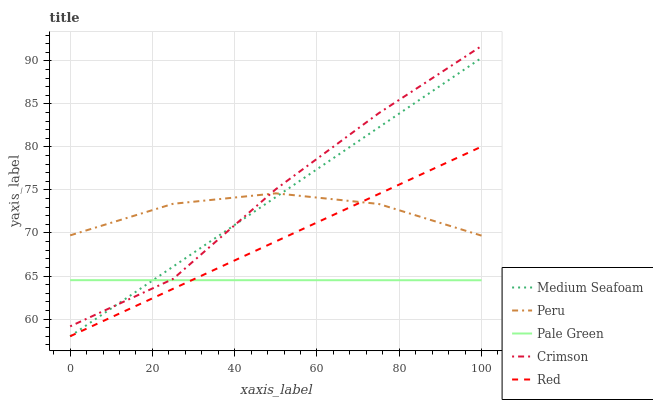Does Pale Green have the minimum area under the curve?
Answer yes or no. Yes. Does Crimson have the maximum area under the curve?
Answer yes or no. Yes. Does Red have the minimum area under the curve?
Answer yes or no. No. Does Red have the maximum area under the curve?
Answer yes or no. No. Is Red the smoothest?
Answer yes or no. Yes. Is Crimson the roughest?
Answer yes or no. Yes. Is Pale Green the smoothest?
Answer yes or no. No. Is Pale Green the roughest?
Answer yes or no. No. Does Red have the lowest value?
Answer yes or no. Yes. Does Pale Green have the lowest value?
Answer yes or no. No. Does Crimson have the highest value?
Answer yes or no. Yes. Does Red have the highest value?
Answer yes or no. No. Is Pale Green less than Peru?
Answer yes or no. Yes. Is Crimson greater than Red?
Answer yes or no. Yes. Does Red intersect Medium Seafoam?
Answer yes or no. Yes. Is Red less than Medium Seafoam?
Answer yes or no. No. Is Red greater than Medium Seafoam?
Answer yes or no. No. Does Pale Green intersect Peru?
Answer yes or no. No. 